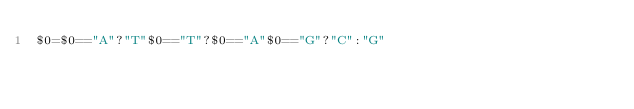Convert code to text. <code><loc_0><loc_0><loc_500><loc_500><_Awk_>$0=$0=="A"?"T"$0=="T"?$0=="A"$0=="G"?"C":"G"</code> 